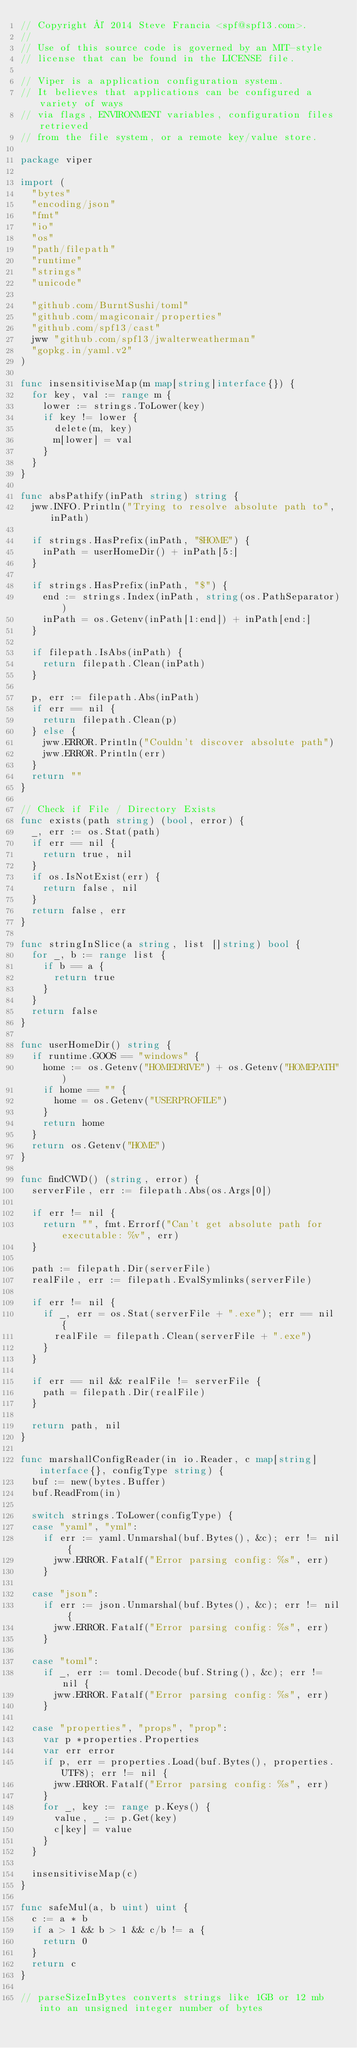<code> <loc_0><loc_0><loc_500><loc_500><_Go_>// Copyright © 2014 Steve Francia <spf@spf13.com>.
//
// Use of this source code is governed by an MIT-style
// license that can be found in the LICENSE file.

// Viper is a application configuration system.
// It believes that applications can be configured a variety of ways
// via flags, ENVIRONMENT variables, configuration files retrieved
// from the file system, or a remote key/value store.

package viper

import (
	"bytes"
	"encoding/json"
	"fmt"
	"io"
	"os"
	"path/filepath"
	"runtime"
	"strings"
	"unicode"

	"github.com/BurntSushi/toml"
	"github.com/magiconair/properties"
	"github.com/spf13/cast"
	jww "github.com/spf13/jwalterweatherman"
	"gopkg.in/yaml.v2"
)

func insensitiviseMap(m map[string]interface{}) {
	for key, val := range m {
		lower := strings.ToLower(key)
		if key != lower {
			delete(m, key)
			m[lower] = val
		}
	}
}

func absPathify(inPath string) string {
	jww.INFO.Println("Trying to resolve absolute path to", inPath)

	if strings.HasPrefix(inPath, "$HOME") {
		inPath = userHomeDir() + inPath[5:]
	}

	if strings.HasPrefix(inPath, "$") {
		end := strings.Index(inPath, string(os.PathSeparator))
		inPath = os.Getenv(inPath[1:end]) + inPath[end:]
	}

	if filepath.IsAbs(inPath) {
		return filepath.Clean(inPath)
	}

	p, err := filepath.Abs(inPath)
	if err == nil {
		return filepath.Clean(p)
	} else {
		jww.ERROR.Println("Couldn't discover absolute path")
		jww.ERROR.Println(err)
	}
	return ""
}

// Check if File / Directory Exists
func exists(path string) (bool, error) {
	_, err := os.Stat(path)
	if err == nil {
		return true, nil
	}
	if os.IsNotExist(err) {
		return false, nil
	}
	return false, err
}

func stringInSlice(a string, list []string) bool {
	for _, b := range list {
		if b == a {
			return true
		}
	}
	return false
}

func userHomeDir() string {
	if runtime.GOOS == "windows" {
		home := os.Getenv("HOMEDRIVE") + os.Getenv("HOMEPATH")
		if home == "" {
			home = os.Getenv("USERPROFILE")
		}
		return home
	}
	return os.Getenv("HOME")
}

func findCWD() (string, error) {
	serverFile, err := filepath.Abs(os.Args[0])

	if err != nil {
		return "", fmt.Errorf("Can't get absolute path for executable: %v", err)
	}

	path := filepath.Dir(serverFile)
	realFile, err := filepath.EvalSymlinks(serverFile)

	if err != nil {
		if _, err = os.Stat(serverFile + ".exe"); err == nil {
			realFile = filepath.Clean(serverFile + ".exe")
		}
	}

	if err == nil && realFile != serverFile {
		path = filepath.Dir(realFile)
	}

	return path, nil
}

func marshallConfigReader(in io.Reader, c map[string]interface{}, configType string) {
	buf := new(bytes.Buffer)
	buf.ReadFrom(in)

	switch strings.ToLower(configType) {
	case "yaml", "yml":
		if err := yaml.Unmarshal(buf.Bytes(), &c); err != nil {
			jww.ERROR.Fatalf("Error parsing config: %s", err)
		}

	case "json":
		if err := json.Unmarshal(buf.Bytes(), &c); err != nil {
			jww.ERROR.Fatalf("Error parsing config: %s", err)
		}

	case "toml":
		if _, err := toml.Decode(buf.String(), &c); err != nil {
			jww.ERROR.Fatalf("Error parsing config: %s", err)
		}

	case "properties", "props", "prop":
		var p *properties.Properties
		var err error
		if p, err = properties.Load(buf.Bytes(), properties.UTF8); err != nil {
			jww.ERROR.Fatalf("Error parsing config: %s", err)
		}
		for _, key := range p.Keys() {
			value, _ := p.Get(key)
			c[key] = value
		}
	}

	insensitiviseMap(c)
}

func safeMul(a, b uint) uint {
	c := a * b
	if a > 1 && b > 1 && c/b != a {
		return 0
	}
	return c
}

// parseSizeInBytes converts strings like 1GB or 12 mb into an unsigned integer number of bytes</code> 